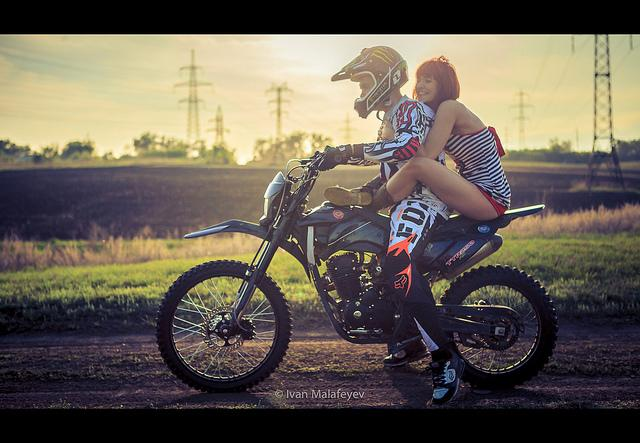Who is wearing the most safety gear?

Choices:
A) bike
B) no one
C) man
D) woman man 